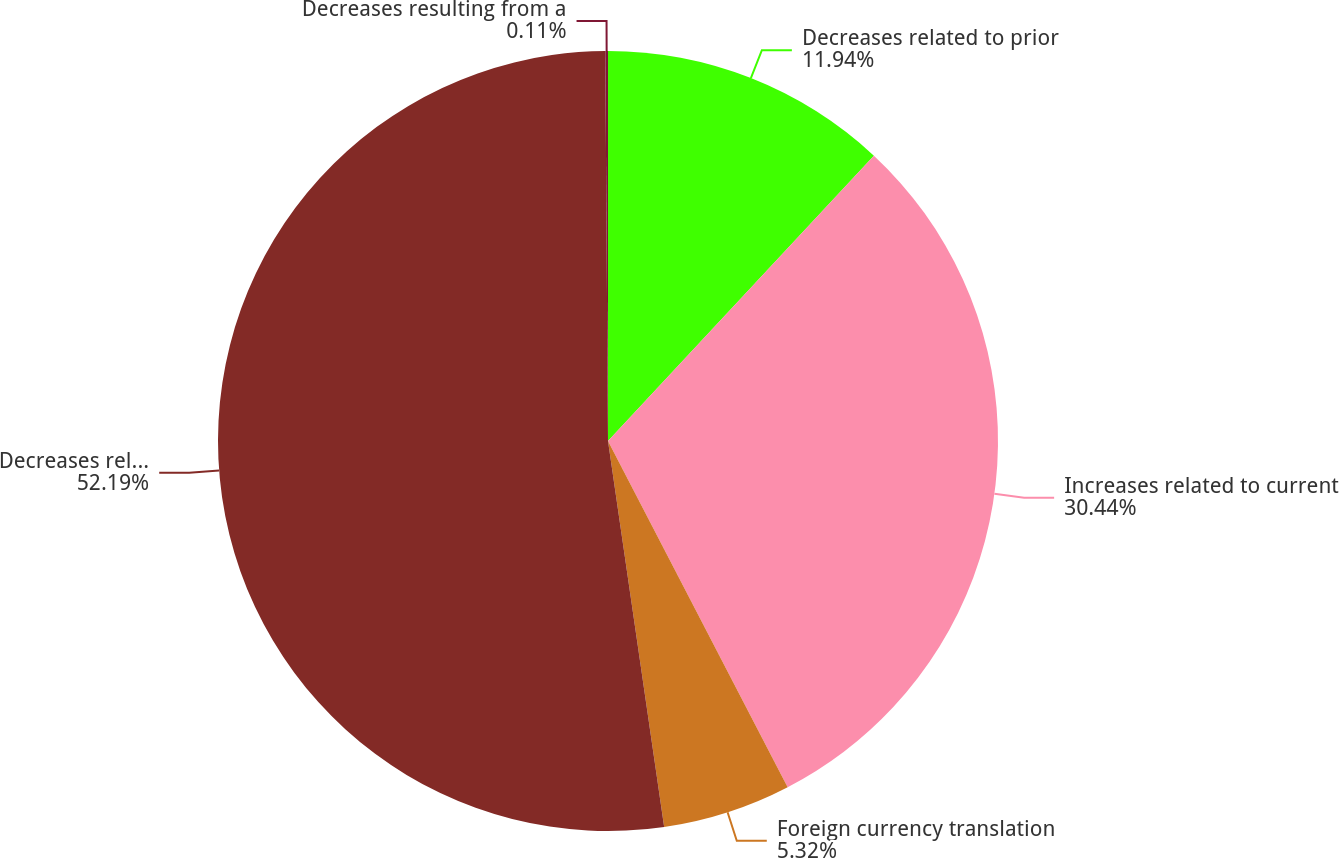<chart> <loc_0><loc_0><loc_500><loc_500><pie_chart><fcel>Decreases related to prior<fcel>Increases related to current<fcel>Foreign currency translation<fcel>Decreases relating to taxing<fcel>Decreases resulting from a<nl><fcel>11.94%<fcel>30.44%<fcel>5.32%<fcel>52.19%<fcel>0.11%<nl></chart> 